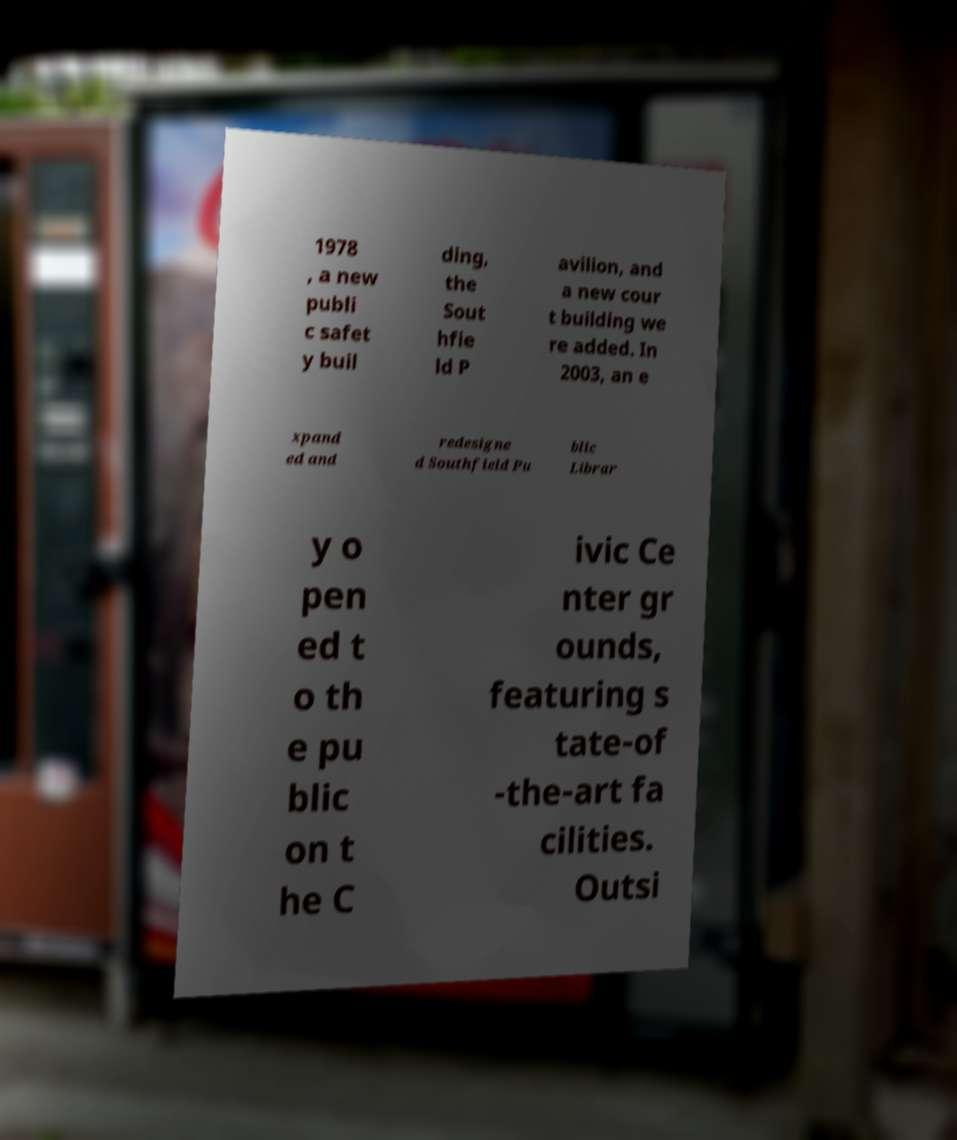Can you read and provide the text displayed in the image?This photo seems to have some interesting text. Can you extract and type it out for me? 1978 , a new publi c safet y buil ding, the Sout hfie ld P avilion, and a new cour t building we re added. In 2003, an e xpand ed and redesigne d Southfield Pu blic Librar y o pen ed t o th e pu blic on t he C ivic Ce nter gr ounds, featuring s tate-of -the-art fa cilities. Outsi 